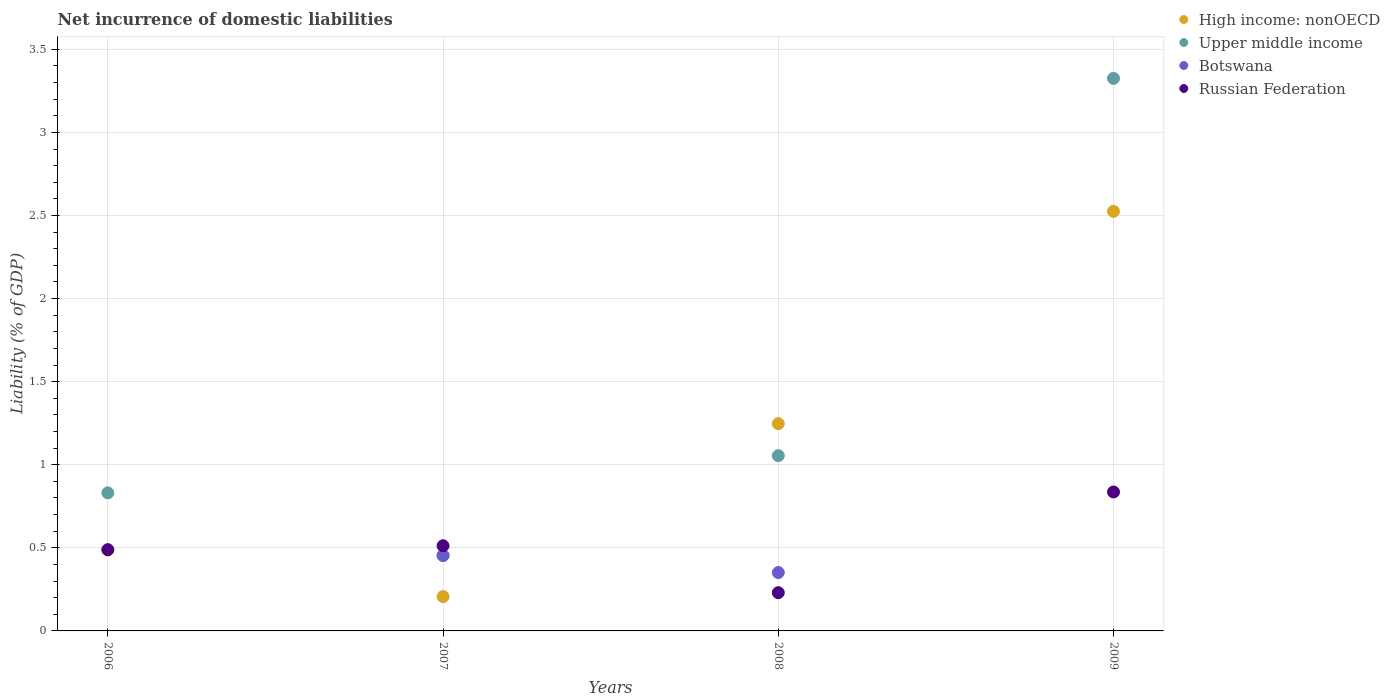How many different coloured dotlines are there?
Your answer should be very brief. 4. What is the net incurrence of domestic liabilities in Upper middle income in 2009?
Offer a terse response. 3.33. Across all years, what is the maximum net incurrence of domestic liabilities in Botswana?
Make the answer very short. 0.45. Across all years, what is the minimum net incurrence of domestic liabilities in High income: nonOECD?
Offer a very short reply. 0.21. What is the total net incurrence of domestic liabilities in High income: nonOECD in the graph?
Provide a succinct answer. 4.47. What is the difference between the net incurrence of domestic liabilities in Russian Federation in 2006 and that in 2009?
Provide a succinct answer. -0.35. What is the difference between the net incurrence of domestic liabilities in Botswana in 2008 and the net incurrence of domestic liabilities in Upper middle income in 2009?
Keep it short and to the point. -2.97. What is the average net incurrence of domestic liabilities in High income: nonOECD per year?
Make the answer very short. 1.12. In the year 2006, what is the difference between the net incurrence of domestic liabilities in High income: nonOECD and net incurrence of domestic liabilities in Upper middle income?
Offer a very short reply. -0.34. In how many years, is the net incurrence of domestic liabilities in Botswana greater than 2.4 %?
Your response must be concise. 0. What is the ratio of the net incurrence of domestic liabilities in Botswana in 2007 to that in 2008?
Keep it short and to the point. 1.29. Is the net incurrence of domestic liabilities in Upper middle income in 2006 less than that in 2008?
Offer a terse response. Yes. What is the difference between the highest and the second highest net incurrence of domestic liabilities in Russian Federation?
Your answer should be compact. 0.32. What is the difference between the highest and the lowest net incurrence of domestic liabilities in High income: nonOECD?
Provide a short and direct response. 2.32. Is the sum of the net incurrence of domestic liabilities in Upper middle income in 2007 and 2009 greater than the maximum net incurrence of domestic liabilities in Russian Federation across all years?
Your response must be concise. Yes. How many dotlines are there?
Give a very brief answer. 4. What is the difference between two consecutive major ticks on the Y-axis?
Provide a short and direct response. 0.5. Does the graph contain any zero values?
Offer a very short reply. Yes. What is the title of the graph?
Your answer should be very brief. Net incurrence of domestic liabilities. Does "Spain" appear as one of the legend labels in the graph?
Provide a short and direct response. No. What is the label or title of the X-axis?
Keep it short and to the point. Years. What is the label or title of the Y-axis?
Make the answer very short. Liability (% of GDP). What is the Liability (% of GDP) in High income: nonOECD in 2006?
Provide a succinct answer. 0.49. What is the Liability (% of GDP) in Upper middle income in 2006?
Your response must be concise. 0.83. What is the Liability (% of GDP) in Botswana in 2006?
Keep it short and to the point. 0. What is the Liability (% of GDP) in Russian Federation in 2006?
Provide a succinct answer. 0.49. What is the Liability (% of GDP) in High income: nonOECD in 2007?
Your answer should be very brief. 0.21. What is the Liability (% of GDP) in Upper middle income in 2007?
Provide a short and direct response. 0.45. What is the Liability (% of GDP) in Botswana in 2007?
Give a very brief answer. 0.45. What is the Liability (% of GDP) in Russian Federation in 2007?
Give a very brief answer. 0.51. What is the Liability (% of GDP) of High income: nonOECD in 2008?
Make the answer very short. 1.25. What is the Liability (% of GDP) in Upper middle income in 2008?
Your response must be concise. 1.05. What is the Liability (% of GDP) of Botswana in 2008?
Your response must be concise. 0.35. What is the Liability (% of GDP) of Russian Federation in 2008?
Provide a short and direct response. 0.23. What is the Liability (% of GDP) in High income: nonOECD in 2009?
Your answer should be very brief. 2.52. What is the Liability (% of GDP) in Upper middle income in 2009?
Ensure brevity in your answer.  3.33. What is the Liability (% of GDP) of Russian Federation in 2009?
Offer a very short reply. 0.84. Across all years, what is the maximum Liability (% of GDP) of High income: nonOECD?
Your response must be concise. 2.52. Across all years, what is the maximum Liability (% of GDP) in Upper middle income?
Give a very brief answer. 3.33. Across all years, what is the maximum Liability (% of GDP) of Botswana?
Give a very brief answer. 0.45. Across all years, what is the maximum Liability (% of GDP) of Russian Federation?
Ensure brevity in your answer.  0.84. Across all years, what is the minimum Liability (% of GDP) of High income: nonOECD?
Keep it short and to the point. 0.21. Across all years, what is the minimum Liability (% of GDP) of Upper middle income?
Provide a succinct answer. 0.45. Across all years, what is the minimum Liability (% of GDP) of Russian Federation?
Provide a succinct answer. 0.23. What is the total Liability (% of GDP) in High income: nonOECD in the graph?
Your answer should be very brief. 4.47. What is the total Liability (% of GDP) of Upper middle income in the graph?
Keep it short and to the point. 5.66. What is the total Liability (% of GDP) in Botswana in the graph?
Your answer should be very brief. 0.81. What is the total Liability (% of GDP) of Russian Federation in the graph?
Offer a terse response. 2.07. What is the difference between the Liability (% of GDP) of High income: nonOECD in 2006 and that in 2007?
Make the answer very short. 0.28. What is the difference between the Liability (% of GDP) in Upper middle income in 2006 and that in 2007?
Your response must be concise. 0.38. What is the difference between the Liability (% of GDP) of Russian Federation in 2006 and that in 2007?
Ensure brevity in your answer.  -0.02. What is the difference between the Liability (% of GDP) in High income: nonOECD in 2006 and that in 2008?
Your response must be concise. -0.76. What is the difference between the Liability (% of GDP) in Upper middle income in 2006 and that in 2008?
Your answer should be very brief. -0.22. What is the difference between the Liability (% of GDP) in Russian Federation in 2006 and that in 2008?
Provide a short and direct response. 0.26. What is the difference between the Liability (% of GDP) of High income: nonOECD in 2006 and that in 2009?
Your response must be concise. -2.04. What is the difference between the Liability (% of GDP) in Upper middle income in 2006 and that in 2009?
Provide a short and direct response. -2.49. What is the difference between the Liability (% of GDP) of Russian Federation in 2006 and that in 2009?
Your response must be concise. -0.35. What is the difference between the Liability (% of GDP) in High income: nonOECD in 2007 and that in 2008?
Provide a succinct answer. -1.04. What is the difference between the Liability (% of GDP) of Upper middle income in 2007 and that in 2008?
Your answer should be very brief. -0.6. What is the difference between the Liability (% of GDP) in Botswana in 2007 and that in 2008?
Make the answer very short. 0.1. What is the difference between the Liability (% of GDP) in Russian Federation in 2007 and that in 2008?
Keep it short and to the point. 0.28. What is the difference between the Liability (% of GDP) of High income: nonOECD in 2007 and that in 2009?
Your answer should be very brief. -2.32. What is the difference between the Liability (% of GDP) in Upper middle income in 2007 and that in 2009?
Your response must be concise. -2.87. What is the difference between the Liability (% of GDP) in Russian Federation in 2007 and that in 2009?
Keep it short and to the point. -0.32. What is the difference between the Liability (% of GDP) in High income: nonOECD in 2008 and that in 2009?
Your answer should be very brief. -1.28. What is the difference between the Liability (% of GDP) of Upper middle income in 2008 and that in 2009?
Your response must be concise. -2.27. What is the difference between the Liability (% of GDP) in Russian Federation in 2008 and that in 2009?
Keep it short and to the point. -0.61. What is the difference between the Liability (% of GDP) of High income: nonOECD in 2006 and the Liability (% of GDP) of Upper middle income in 2007?
Your answer should be compact. 0.03. What is the difference between the Liability (% of GDP) in High income: nonOECD in 2006 and the Liability (% of GDP) in Botswana in 2007?
Give a very brief answer. 0.03. What is the difference between the Liability (% of GDP) in High income: nonOECD in 2006 and the Liability (% of GDP) in Russian Federation in 2007?
Provide a succinct answer. -0.03. What is the difference between the Liability (% of GDP) of Upper middle income in 2006 and the Liability (% of GDP) of Botswana in 2007?
Provide a succinct answer. 0.38. What is the difference between the Liability (% of GDP) in Upper middle income in 2006 and the Liability (% of GDP) in Russian Federation in 2007?
Keep it short and to the point. 0.32. What is the difference between the Liability (% of GDP) in High income: nonOECD in 2006 and the Liability (% of GDP) in Upper middle income in 2008?
Provide a succinct answer. -0.57. What is the difference between the Liability (% of GDP) in High income: nonOECD in 2006 and the Liability (% of GDP) in Botswana in 2008?
Your answer should be very brief. 0.14. What is the difference between the Liability (% of GDP) in High income: nonOECD in 2006 and the Liability (% of GDP) in Russian Federation in 2008?
Keep it short and to the point. 0.26. What is the difference between the Liability (% of GDP) in Upper middle income in 2006 and the Liability (% of GDP) in Botswana in 2008?
Your response must be concise. 0.48. What is the difference between the Liability (% of GDP) in Upper middle income in 2006 and the Liability (% of GDP) in Russian Federation in 2008?
Make the answer very short. 0.6. What is the difference between the Liability (% of GDP) of High income: nonOECD in 2006 and the Liability (% of GDP) of Upper middle income in 2009?
Provide a succinct answer. -2.84. What is the difference between the Liability (% of GDP) in High income: nonOECD in 2006 and the Liability (% of GDP) in Russian Federation in 2009?
Your response must be concise. -0.35. What is the difference between the Liability (% of GDP) in Upper middle income in 2006 and the Liability (% of GDP) in Russian Federation in 2009?
Your response must be concise. -0.01. What is the difference between the Liability (% of GDP) in High income: nonOECD in 2007 and the Liability (% of GDP) in Upper middle income in 2008?
Keep it short and to the point. -0.85. What is the difference between the Liability (% of GDP) of High income: nonOECD in 2007 and the Liability (% of GDP) of Botswana in 2008?
Provide a succinct answer. -0.14. What is the difference between the Liability (% of GDP) of High income: nonOECD in 2007 and the Liability (% of GDP) of Russian Federation in 2008?
Offer a terse response. -0.02. What is the difference between the Liability (% of GDP) of Upper middle income in 2007 and the Liability (% of GDP) of Botswana in 2008?
Provide a short and direct response. 0.1. What is the difference between the Liability (% of GDP) of Upper middle income in 2007 and the Liability (% of GDP) of Russian Federation in 2008?
Make the answer very short. 0.22. What is the difference between the Liability (% of GDP) of Botswana in 2007 and the Liability (% of GDP) of Russian Federation in 2008?
Offer a terse response. 0.22. What is the difference between the Liability (% of GDP) in High income: nonOECD in 2007 and the Liability (% of GDP) in Upper middle income in 2009?
Offer a very short reply. -3.12. What is the difference between the Liability (% of GDP) of High income: nonOECD in 2007 and the Liability (% of GDP) of Russian Federation in 2009?
Your answer should be very brief. -0.63. What is the difference between the Liability (% of GDP) of Upper middle income in 2007 and the Liability (% of GDP) of Russian Federation in 2009?
Offer a terse response. -0.38. What is the difference between the Liability (% of GDP) of Botswana in 2007 and the Liability (% of GDP) of Russian Federation in 2009?
Your answer should be compact. -0.38. What is the difference between the Liability (% of GDP) in High income: nonOECD in 2008 and the Liability (% of GDP) in Upper middle income in 2009?
Keep it short and to the point. -2.08. What is the difference between the Liability (% of GDP) in High income: nonOECD in 2008 and the Liability (% of GDP) in Russian Federation in 2009?
Make the answer very short. 0.41. What is the difference between the Liability (% of GDP) in Upper middle income in 2008 and the Liability (% of GDP) in Russian Federation in 2009?
Your answer should be compact. 0.22. What is the difference between the Liability (% of GDP) in Botswana in 2008 and the Liability (% of GDP) in Russian Federation in 2009?
Give a very brief answer. -0.48. What is the average Liability (% of GDP) of High income: nonOECD per year?
Your response must be concise. 1.12. What is the average Liability (% of GDP) in Upper middle income per year?
Offer a very short reply. 1.42. What is the average Liability (% of GDP) of Botswana per year?
Offer a terse response. 0.2. What is the average Liability (% of GDP) in Russian Federation per year?
Your answer should be compact. 0.52. In the year 2006, what is the difference between the Liability (% of GDP) in High income: nonOECD and Liability (% of GDP) in Upper middle income?
Your response must be concise. -0.34. In the year 2006, what is the difference between the Liability (% of GDP) of High income: nonOECD and Liability (% of GDP) of Russian Federation?
Make the answer very short. -0. In the year 2006, what is the difference between the Liability (% of GDP) of Upper middle income and Liability (% of GDP) of Russian Federation?
Keep it short and to the point. 0.34. In the year 2007, what is the difference between the Liability (% of GDP) of High income: nonOECD and Liability (% of GDP) of Upper middle income?
Provide a succinct answer. -0.25. In the year 2007, what is the difference between the Liability (% of GDP) of High income: nonOECD and Liability (% of GDP) of Botswana?
Make the answer very short. -0.25. In the year 2007, what is the difference between the Liability (% of GDP) in High income: nonOECD and Liability (% of GDP) in Russian Federation?
Your answer should be compact. -0.31. In the year 2007, what is the difference between the Liability (% of GDP) in Upper middle income and Liability (% of GDP) in Russian Federation?
Make the answer very short. -0.06. In the year 2007, what is the difference between the Liability (% of GDP) of Botswana and Liability (% of GDP) of Russian Federation?
Provide a succinct answer. -0.06. In the year 2008, what is the difference between the Liability (% of GDP) in High income: nonOECD and Liability (% of GDP) in Upper middle income?
Make the answer very short. 0.19. In the year 2008, what is the difference between the Liability (% of GDP) in High income: nonOECD and Liability (% of GDP) in Botswana?
Give a very brief answer. 0.9. In the year 2008, what is the difference between the Liability (% of GDP) in High income: nonOECD and Liability (% of GDP) in Russian Federation?
Provide a short and direct response. 1.02. In the year 2008, what is the difference between the Liability (% of GDP) in Upper middle income and Liability (% of GDP) in Botswana?
Your response must be concise. 0.7. In the year 2008, what is the difference between the Liability (% of GDP) of Upper middle income and Liability (% of GDP) of Russian Federation?
Provide a succinct answer. 0.82. In the year 2008, what is the difference between the Liability (% of GDP) in Botswana and Liability (% of GDP) in Russian Federation?
Your response must be concise. 0.12. In the year 2009, what is the difference between the Liability (% of GDP) in High income: nonOECD and Liability (% of GDP) in Upper middle income?
Your response must be concise. -0.8. In the year 2009, what is the difference between the Liability (% of GDP) in High income: nonOECD and Liability (% of GDP) in Russian Federation?
Keep it short and to the point. 1.69. In the year 2009, what is the difference between the Liability (% of GDP) in Upper middle income and Liability (% of GDP) in Russian Federation?
Your response must be concise. 2.49. What is the ratio of the Liability (% of GDP) in High income: nonOECD in 2006 to that in 2007?
Keep it short and to the point. 2.36. What is the ratio of the Liability (% of GDP) of Upper middle income in 2006 to that in 2007?
Your answer should be very brief. 1.83. What is the ratio of the Liability (% of GDP) of Russian Federation in 2006 to that in 2007?
Give a very brief answer. 0.95. What is the ratio of the Liability (% of GDP) of High income: nonOECD in 2006 to that in 2008?
Your response must be concise. 0.39. What is the ratio of the Liability (% of GDP) in Upper middle income in 2006 to that in 2008?
Give a very brief answer. 0.79. What is the ratio of the Liability (% of GDP) of Russian Federation in 2006 to that in 2008?
Ensure brevity in your answer.  2.12. What is the ratio of the Liability (% of GDP) in High income: nonOECD in 2006 to that in 2009?
Your response must be concise. 0.19. What is the ratio of the Liability (% of GDP) of Upper middle income in 2006 to that in 2009?
Give a very brief answer. 0.25. What is the ratio of the Liability (% of GDP) of Russian Federation in 2006 to that in 2009?
Provide a short and direct response. 0.58. What is the ratio of the Liability (% of GDP) of High income: nonOECD in 2007 to that in 2008?
Ensure brevity in your answer.  0.17. What is the ratio of the Liability (% of GDP) of Upper middle income in 2007 to that in 2008?
Give a very brief answer. 0.43. What is the ratio of the Liability (% of GDP) of Botswana in 2007 to that in 2008?
Make the answer very short. 1.29. What is the ratio of the Liability (% of GDP) in Russian Federation in 2007 to that in 2008?
Keep it short and to the point. 2.23. What is the ratio of the Liability (% of GDP) of High income: nonOECD in 2007 to that in 2009?
Provide a succinct answer. 0.08. What is the ratio of the Liability (% of GDP) of Upper middle income in 2007 to that in 2009?
Provide a succinct answer. 0.14. What is the ratio of the Liability (% of GDP) in Russian Federation in 2007 to that in 2009?
Offer a very short reply. 0.61. What is the ratio of the Liability (% of GDP) in High income: nonOECD in 2008 to that in 2009?
Provide a short and direct response. 0.49. What is the ratio of the Liability (% of GDP) of Upper middle income in 2008 to that in 2009?
Your answer should be compact. 0.32. What is the ratio of the Liability (% of GDP) of Russian Federation in 2008 to that in 2009?
Make the answer very short. 0.28. What is the difference between the highest and the second highest Liability (% of GDP) in High income: nonOECD?
Your response must be concise. 1.28. What is the difference between the highest and the second highest Liability (% of GDP) of Upper middle income?
Offer a very short reply. 2.27. What is the difference between the highest and the second highest Liability (% of GDP) of Russian Federation?
Your response must be concise. 0.32. What is the difference between the highest and the lowest Liability (% of GDP) of High income: nonOECD?
Keep it short and to the point. 2.32. What is the difference between the highest and the lowest Liability (% of GDP) of Upper middle income?
Provide a short and direct response. 2.87. What is the difference between the highest and the lowest Liability (% of GDP) of Botswana?
Provide a succinct answer. 0.45. What is the difference between the highest and the lowest Liability (% of GDP) in Russian Federation?
Your answer should be very brief. 0.61. 